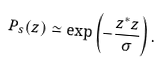Convert formula to latex. <formula><loc_0><loc_0><loc_500><loc_500>P _ { s } ( z ) \simeq \exp { \left ( - \frac { z ^ { * } z } { \sigma } \right ) } \, .</formula> 